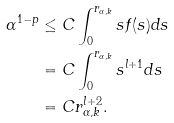Convert formula to latex. <formula><loc_0><loc_0><loc_500><loc_500>\alpha ^ { 1 - p } & \leq C \int _ { 0 } ^ { r _ { \alpha , k } } s f ( s ) d s \\ & = C \int _ { 0 } ^ { r _ { \alpha , k } } s ^ { l + 1 } d s \\ & = C r _ { \alpha , k } ^ { l + 2 } .</formula> 